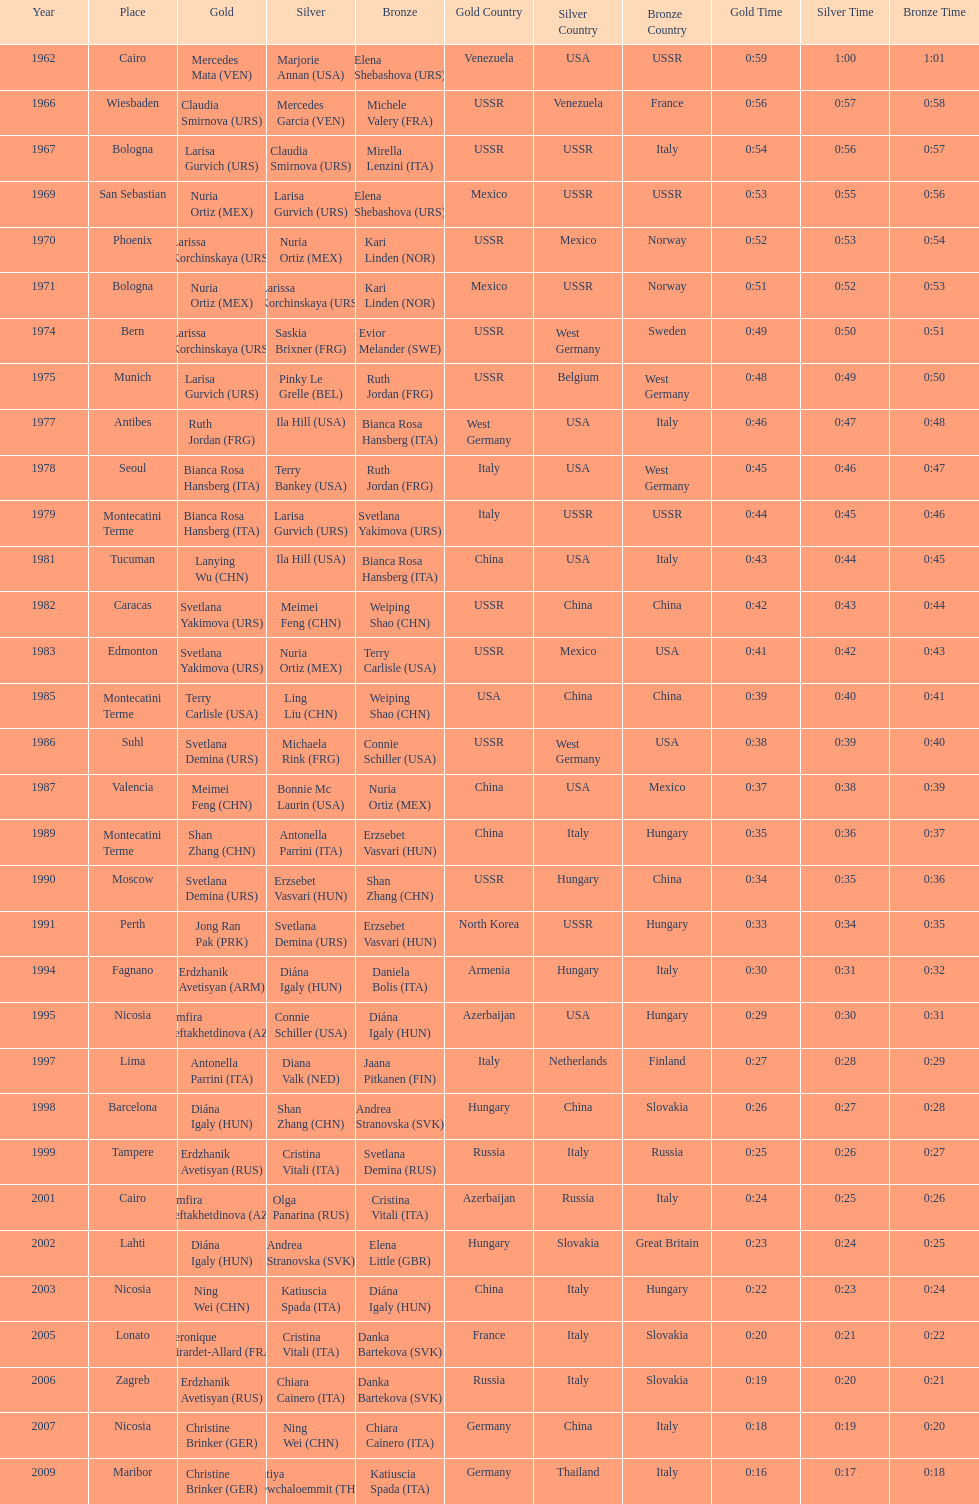Can you give me this table as a dict? {'header': ['Year', 'Place', 'Gold', 'Silver', 'Bronze', 'Gold Country', 'Silver Country', 'Bronze Country', 'Gold Time', 'Silver Time', 'Bronze Time'], 'rows': [['1962', 'Cairo', 'Mercedes Mata\xa0(VEN)', 'Marjorie Annan\xa0(USA)', 'Elena Shebashova\xa0(URS)', 'Venezuela', 'USA', 'USSR', '0:59', '1:00', '1:01'], ['1966', 'Wiesbaden', 'Claudia Smirnova\xa0(URS)', 'Mercedes Garcia\xa0(VEN)', 'Michele Valery\xa0(FRA)', 'USSR', 'Venezuela', 'France', '0:56', '0:57', '0:58'], ['1967', 'Bologna', 'Larisa Gurvich\xa0(URS)', 'Claudia Smirnova\xa0(URS)', 'Mirella Lenzini\xa0(ITA)', 'USSR', 'USSR', 'Italy', '0:54', '0:56', '0:57'], ['1969', 'San Sebastian', 'Nuria Ortiz\xa0(MEX)', 'Larisa Gurvich\xa0(URS)', 'Elena Shebashova\xa0(URS)', 'Mexico', 'USSR', 'USSR', '0:53', '0:55', '0:56'], ['1970', 'Phoenix', 'Larissa Korchinskaya\xa0(URS)', 'Nuria Ortiz\xa0(MEX)', 'Kari Linden\xa0(NOR)', 'USSR', 'Mexico', 'Norway', '0:52', '0:53', '0:54'], ['1971', 'Bologna', 'Nuria Ortiz\xa0(MEX)', 'Larissa Korchinskaya\xa0(URS)', 'Kari Linden\xa0(NOR)', 'Mexico', 'USSR', 'Norway', '0:51', '0:52', '0:53'], ['1974', 'Bern', 'Larissa Korchinskaya\xa0(URS)', 'Saskia Brixner\xa0(FRG)', 'Evior Melander\xa0(SWE)', 'USSR', 'West Germany', 'Sweden', '0:49', '0:50', '0:51'], ['1975', 'Munich', 'Larisa Gurvich\xa0(URS)', 'Pinky Le Grelle\xa0(BEL)', 'Ruth Jordan\xa0(FRG)', 'USSR', 'Belgium', 'West Germany', '0:48', '0:49', '0:50'], ['1977', 'Antibes', 'Ruth Jordan\xa0(FRG)', 'Ila Hill\xa0(USA)', 'Bianca Rosa Hansberg\xa0(ITA)', 'West Germany', 'USA', 'Italy', '0:46', '0:47', '0:48'], ['1978', 'Seoul', 'Bianca Rosa Hansberg\xa0(ITA)', 'Terry Bankey\xa0(USA)', 'Ruth Jordan\xa0(FRG)', 'Italy', 'USA', 'West Germany', '0:45', '0:46', '0:47'], ['1979', 'Montecatini Terme', 'Bianca Rosa Hansberg\xa0(ITA)', 'Larisa Gurvich\xa0(URS)', 'Svetlana Yakimova\xa0(URS)', 'Italy', 'USSR', 'USSR', '0:44', '0:45', '0:46'], ['1981', 'Tucuman', 'Lanying Wu\xa0(CHN)', 'Ila Hill\xa0(USA)', 'Bianca Rosa Hansberg\xa0(ITA)', 'China', 'USA', 'Italy', '0:43', '0:44', '0:45'], ['1982', 'Caracas', 'Svetlana Yakimova\xa0(URS)', 'Meimei Feng\xa0(CHN)', 'Weiping Shao\xa0(CHN)', 'USSR', 'China', 'China', '0:42', '0:43', '0:44'], ['1983', 'Edmonton', 'Svetlana Yakimova\xa0(URS)', 'Nuria Ortiz\xa0(MEX)', 'Terry Carlisle\xa0(USA)', 'USSR', 'Mexico', 'USA', '0:41', '0:42', '0:43'], ['1985', 'Montecatini Terme', 'Terry Carlisle\xa0(USA)', 'Ling Liu\xa0(CHN)', 'Weiping Shao\xa0(CHN)', 'USA', 'China', 'China', '0:39', '0:40', '0:41'], ['1986', 'Suhl', 'Svetlana Demina\xa0(URS)', 'Michaela Rink\xa0(FRG)', 'Connie Schiller\xa0(USA)', 'USSR', 'West Germany', 'USA', '0:38', '0:39', '0:40'], ['1987', 'Valencia', 'Meimei Feng\xa0(CHN)', 'Bonnie Mc Laurin\xa0(USA)', 'Nuria Ortiz\xa0(MEX)', 'China', 'USA', 'Mexico', '0:37', '0:38', '0:39'], ['1989', 'Montecatini Terme', 'Shan Zhang\xa0(CHN)', 'Antonella Parrini\xa0(ITA)', 'Erzsebet Vasvari\xa0(HUN)', 'China', 'Italy', 'Hungary', '0:35', '0:36', '0:37'], ['1990', 'Moscow', 'Svetlana Demina\xa0(URS)', 'Erzsebet Vasvari\xa0(HUN)', 'Shan Zhang\xa0(CHN)', 'USSR', 'Hungary', 'China', '0:34', '0:35', '0:36'], ['1991', 'Perth', 'Jong Ran Pak\xa0(PRK)', 'Svetlana Demina\xa0(URS)', 'Erzsebet Vasvari\xa0(HUN)', 'North Korea', 'USSR', 'Hungary', '0:33', '0:34', '0:35'], ['1994', 'Fagnano', 'Erdzhanik Avetisyan\xa0(ARM)', 'Diána Igaly\xa0(HUN)', 'Daniela Bolis\xa0(ITA)', 'Armenia', 'Hungary', 'Italy', '0:30', '0:31', '0:32'], ['1995', 'Nicosia', 'Zemfira Meftakhetdinova\xa0(AZE)', 'Connie Schiller\xa0(USA)', 'Diána Igaly\xa0(HUN)', 'Azerbaijan', 'USA', 'Hungary', '0:29', '0:30', '0:31'], ['1997', 'Lima', 'Antonella Parrini\xa0(ITA)', 'Diana Valk\xa0(NED)', 'Jaana Pitkanen\xa0(FIN)', 'Italy', 'Netherlands', 'Finland', '0:27', '0:28', '0:29'], ['1998', 'Barcelona', 'Diána Igaly\xa0(HUN)', 'Shan Zhang\xa0(CHN)', 'Andrea Stranovska\xa0(SVK)', 'Hungary', 'China', 'Slovakia', '0:26', '0:27', '0:28'], ['1999', 'Tampere', 'Erdzhanik Avetisyan\xa0(RUS)', 'Cristina Vitali\xa0(ITA)', 'Svetlana Demina\xa0(RUS)', 'Russia', 'Italy', 'Russia', '0:25', '0:26', '0:27'], ['2001', 'Cairo', 'Zemfira Meftakhetdinova\xa0(AZE)', 'Olga Panarina\xa0(RUS)', 'Cristina Vitali\xa0(ITA)', 'Azerbaijan', 'Russia', 'Italy', '0:24', '0:25', '0:26'], ['2002', 'Lahti', 'Diána Igaly\xa0(HUN)', 'Andrea Stranovska\xa0(SVK)', 'Elena Little\xa0(GBR)', 'Hungary', 'Slovakia', 'Great Britain', '0:23', '0:24', '0:25'], ['2003', 'Nicosia', 'Ning Wei\xa0(CHN)', 'Katiuscia Spada\xa0(ITA)', 'Diána Igaly\xa0(HUN)', 'China', 'Italy', 'Hungary', '0:22', '0:23', '0:24'], ['2005', 'Lonato', 'Veronique Girardet-Allard\xa0(FRA)', 'Cristina Vitali\xa0(ITA)', 'Danka Bartekova\xa0(SVK)', 'France', 'Italy', 'Slovakia', '0:20', '0:21', '0:22'], ['2006', 'Zagreb', 'Erdzhanik Avetisyan\xa0(RUS)', 'Chiara Cainero\xa0(ITA)', 'Danka Bartekova\xa0(SVK)', 'Russia', 'Italy', 'Slovakia', '0:19', '0:20', '0:21'], ['2007', 'Nicosia', 'Christine Brinker\xa0(GER)', 'Ning Wei\xa0(CHN)', 'Chiara Cainero\xa0(ITA)', 'Germany', 'China', 'Italy', '0:18', '0:19', '0:20'], ['2009', 'Maribor', 'Christine Brinker\xa0(GER)', 'Sutiya Jiewchaloemmit\xa0(THA)', 'Katiuscia Spada\xa0(ITA)', 'Germany', 'Thailand', 'Italy', '0:16', '0:17', '0:18']]} Which country has the most bronze medals? Italy. 